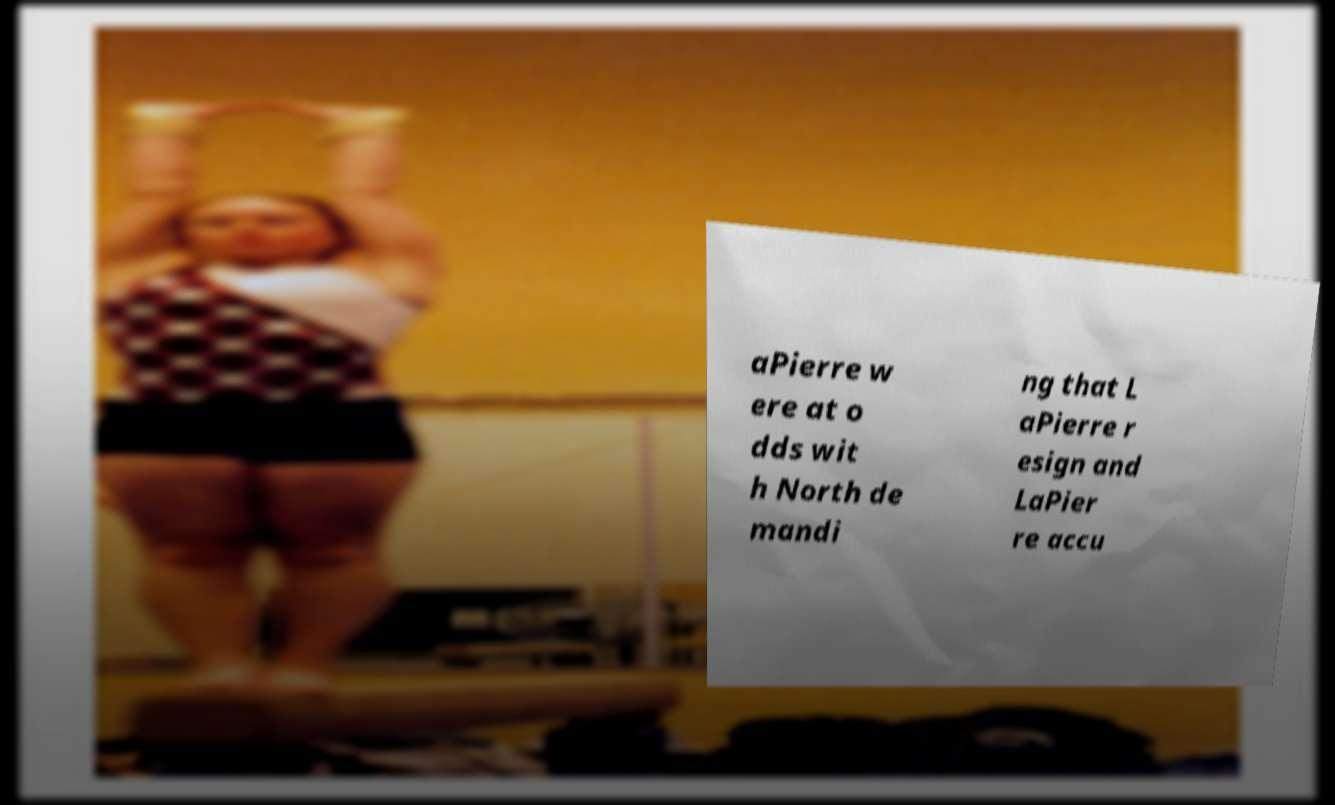Could you extract and type out the text from this image? aPierre w ere at o dds wit h North de mandi ng that L aPierre r esign and LaPier re accu 